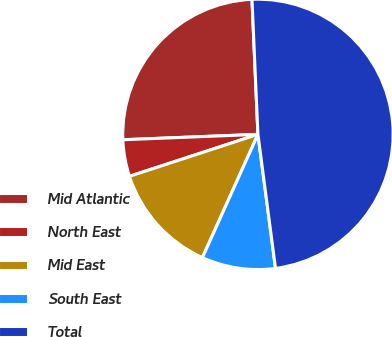<chart> <loc_0><loc_0><loc_500><loc_500><pie_chart><fcel>Mid Atlantic<fcel>North East<fcel>Mid East<fcel>South East<fcel>Total<nl><fcel>24.93%<fcel>4.39%<fcel>13.24%<fcel>8.81%<fcel>48.62%<nl></chart> 